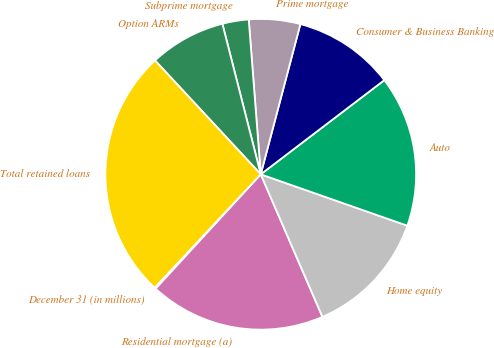Convert chart to OTSL. <chart><loc_0><loc_0><loc_500><loc_500><pie_chart><fcel>December 31 (in millions)<fcel>Residential mortgage (a)<fcel>Home equity<fcel>Auto<fcel>Consumer & Business Banking<fcel>Prime mortgage<fcel>Subprime mortgage<fcel>Option ARMs<fcel>Total retained loans<nl><fcel>0.14%<fcel>18.33%<fcel>13.13%<fcel>15.73%<fcel>10.53%<fcel>5.34%<fcel>2.74%<fcel>7.94%<fcel>26.12%<nl></chart> 